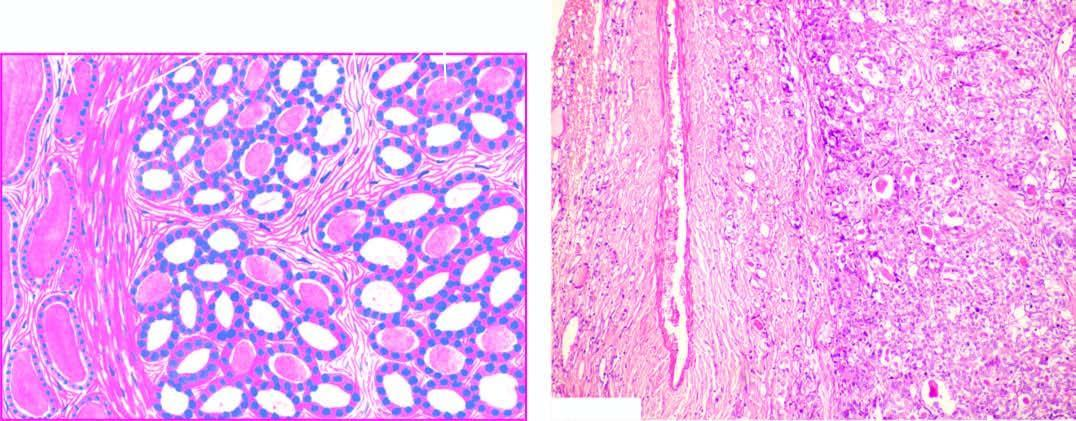s the tumour well-encapsulated with compression of surrounding thyroid parenchyma?
Answer the question using a single word or phrase. Yes 